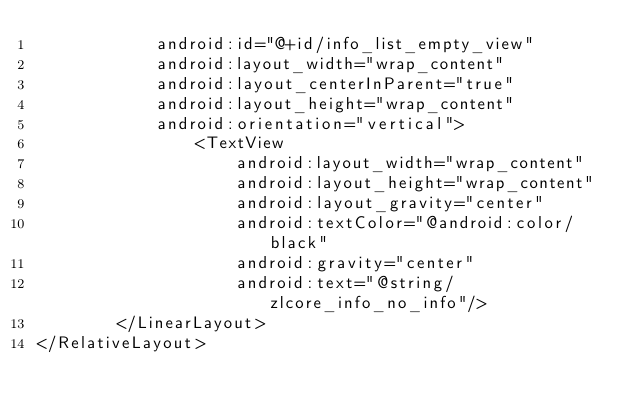<code> <loc_0><loc_0><loc_500><loc_500><_XML_>            android:id="@+id/info_list_empty_view"
            android:layout_width="wrap_content"
            android:layout_centerInParent="true"
            android:layout_height="wrap_content"
            android:orientation="vertical">
                <TextView
                    android:layout_width="wrap_content"
                    android:layout_height="wrap_content"
                    android:layout_gravity="center"
                    android:textColor="@android:color/black"
                    android:gravity="center"
                    android:text="@string/zlcore_info_no_info"/>
        </LinearLayout>
</RelativeLayout></code> 